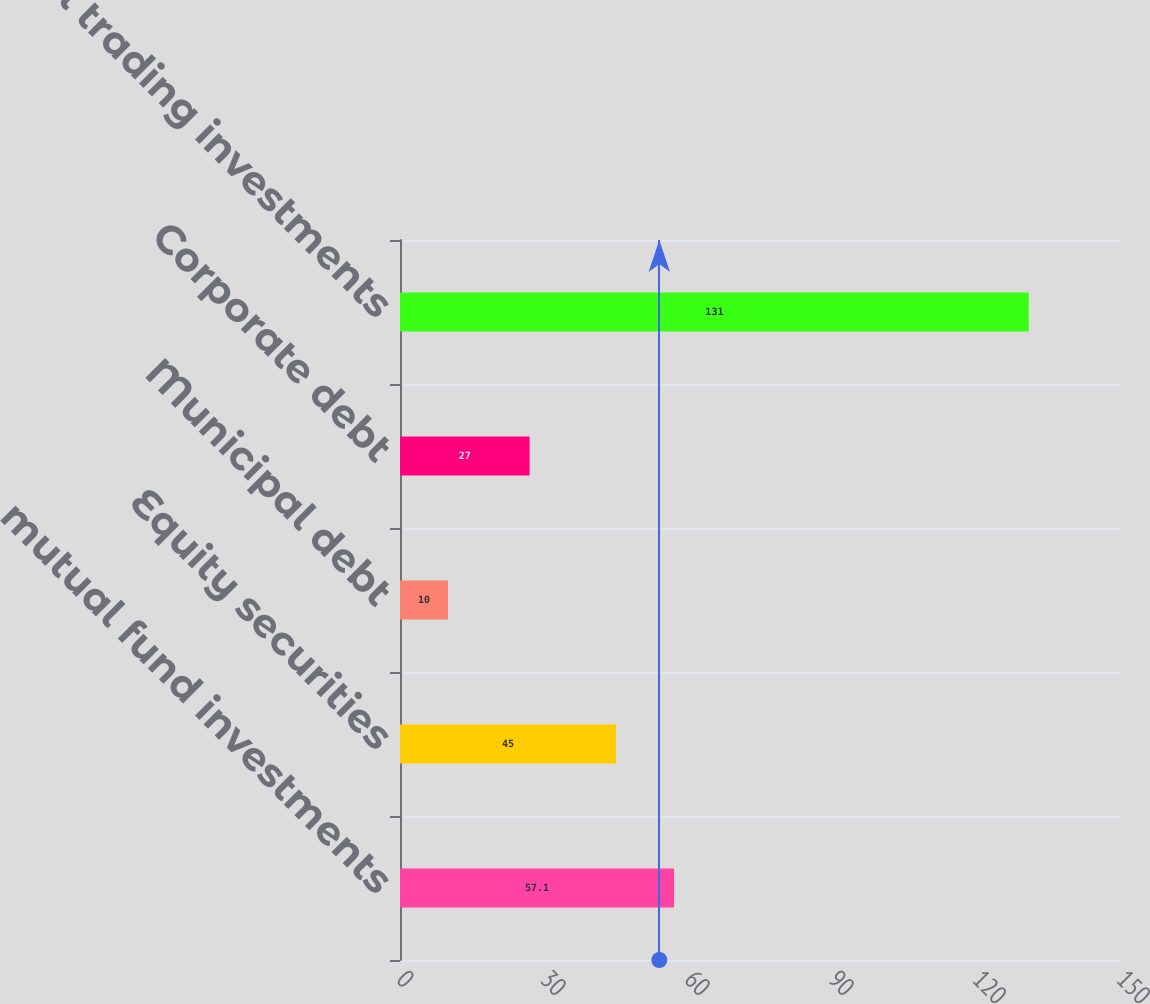<chart> <loc_0><loc_0><loc_500><loc_500><bar_chart><fcel>mutual fund investments<fcel>Equity securities<fcel>Municipal debt<fcel>Corporate debt<fcel>Total trading investments<nl><fcel>57.1<fcel>45<fcel>10<fcel>27<fcel>131<nl></chart> 